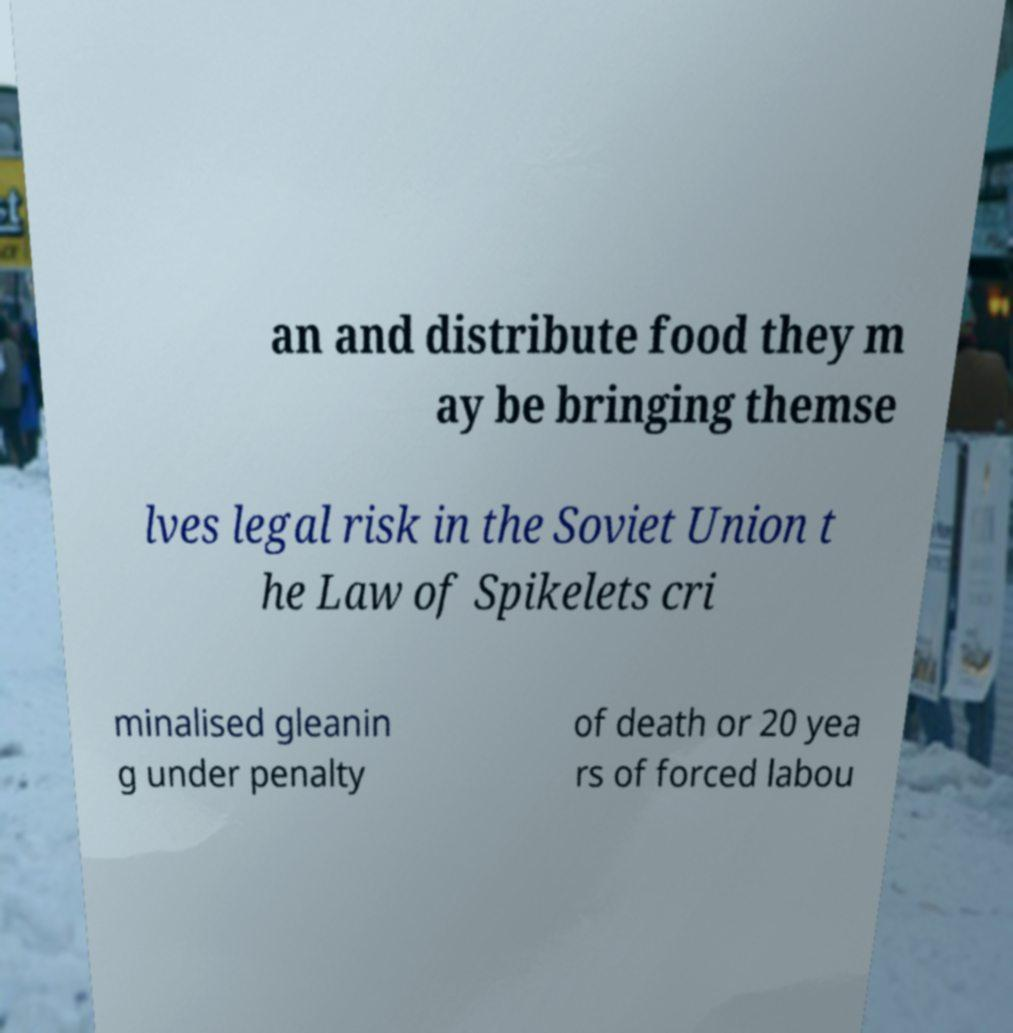Could you assist in decoding the text presented in this image and type it out clearly? an and distribute food they m ay be bringing themse lves legal risk in the Soviet Union t he Law of Spikelets cri minalised gleanin g under penalty of death or 20 yea rs of forced labou 